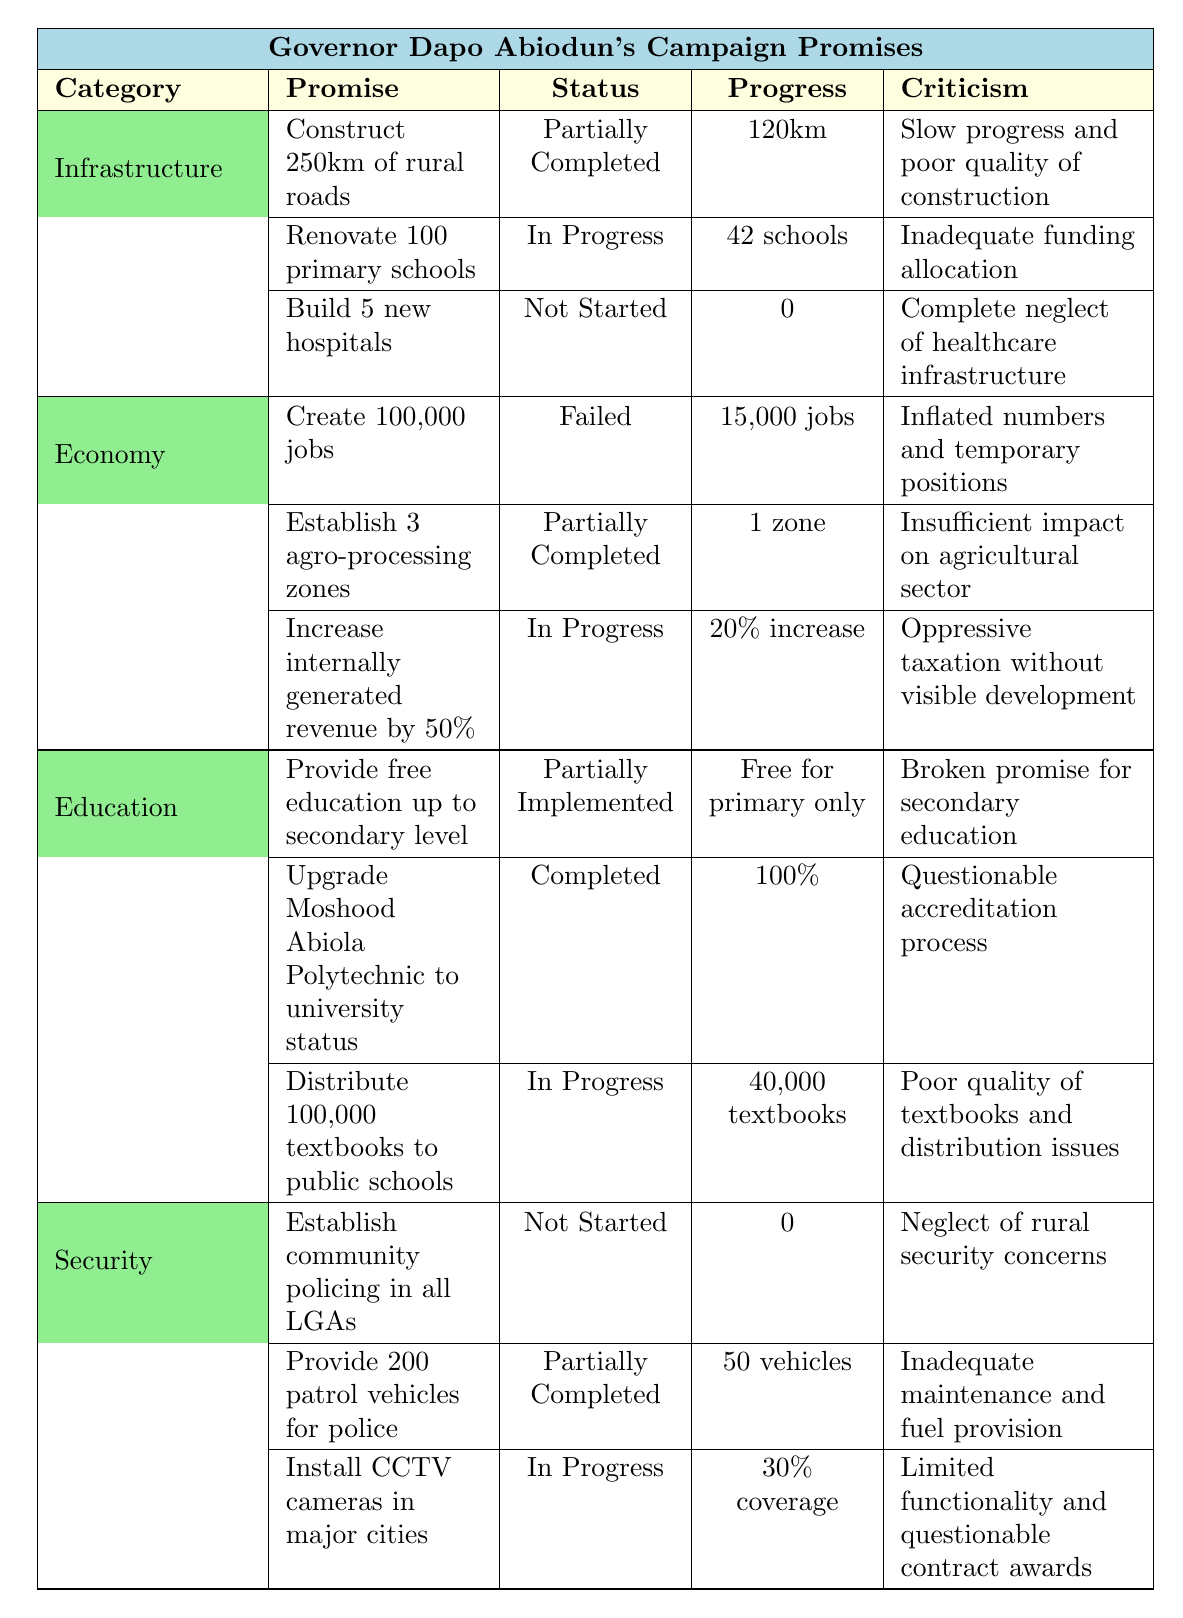What is the implementation status of the promise to construct 250km of rural roads? The table indicates that the status of this promise is "Partially Completed."
Answer: Partially Completed How many hospitals has Governor Dapo Abiodun promised to build? The table states that the promise is to build "5 new hospitals."
Answer: 5 new hospitals What is the progress on the renovation of primary schools? The table shows that 42 schools have been renovated, thus the status is "In Progress."
Answer: 42 schools Which category has the highest number of promises that are not started? The "Security" category has one promise listed as "Not Started."
Answer: Security How many patrol vehicles have been provided to the police according to the table? The table specifies that there have been "50 vehicles" provided.
Answer: 50 vehicles Which education promise has been marked as fully completed? The table highlights the upgrade of Moshood Abiola Polytechnic to university status, marked as "Completed."
Answer: Upgrade of Moshood Abiola Polytechnic What is the total progress made in creating jobs as per the table? The table reports that 15,000 jobs have been created out of a promised 100,000 jobs, which indicates a failure to meet the target.
Answer: 15,000 jobs Is the status of distributing 100,000 textbooks to public schools completely fulfilled? The table indicates that this promise is "In Progress," meaning it is not completely fulfilled.
Answer: No How do the statuses of promises in the "Economy" category compare with those in "Security"? The table shows promises in the "Economy" category have both "Failed" and "Partially Completed" statuses whereas in "Security," there is one that is "Not Started" and two that are "Partially Completed."
Answer: Economy has more failures Considering the criticisms listed, which promise related to infrastructure has the most severe criticism? The promise to build 5 new hospitals has the criticism of "Complete neglect of healthcare infrastructure," which is quite severe compared to others.
Answer: Building new hospitals What percentage of CCTV camera installation has been completed? The table shows that there is a "30% coverage" of CCTV camera installations.
Answer: 30% coverage 